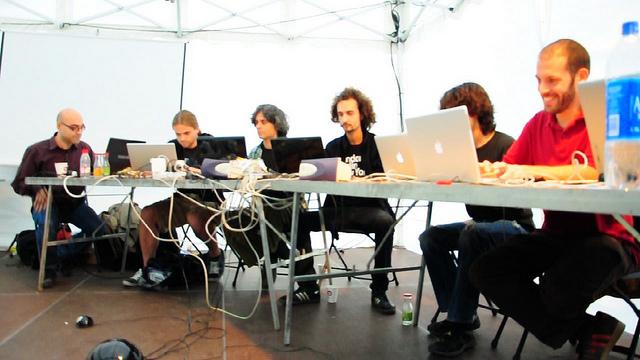Are all the people smiling?
Be succinct. No. Are there refreshments sitting on the floor?
Short answer required. Yes. How many laptops are visible?
Concise answer only. 6. Is the man in red wearing glasses?
Write a very short answer. No. What type of outfits are these people wearing?
Give a very brief answer. Casual. 